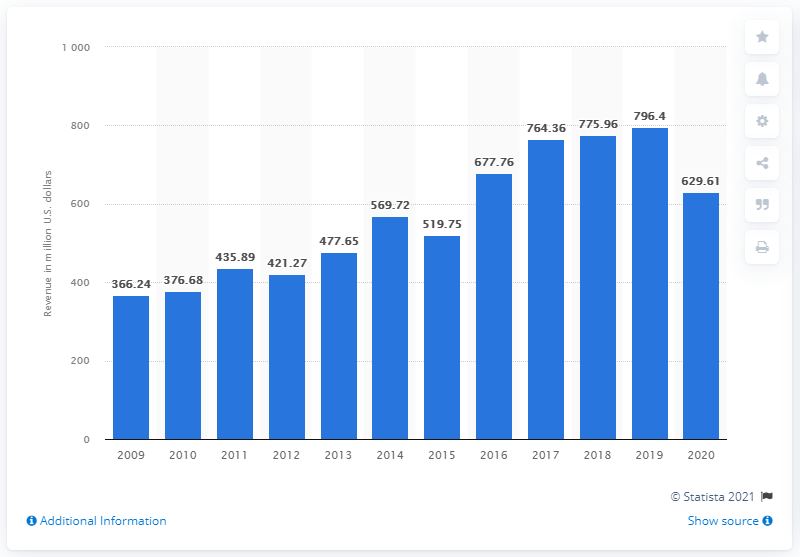Identify some key points in this picture. In the fiscal year 2020, Manchester United generated 629.61 million pounds in revenue. 